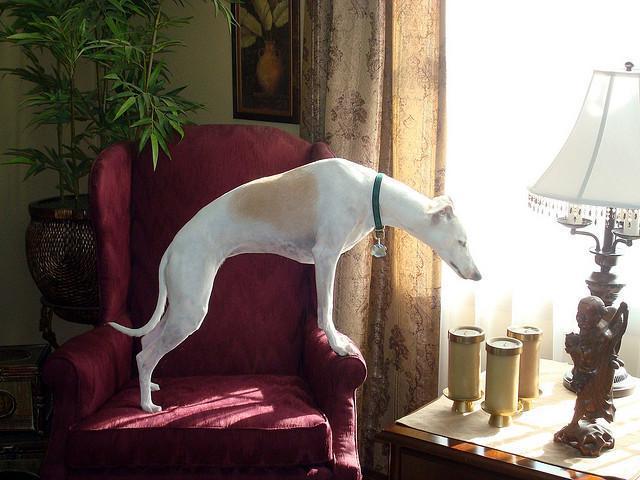How many vases are there?
Give a very brief answer. 2. 